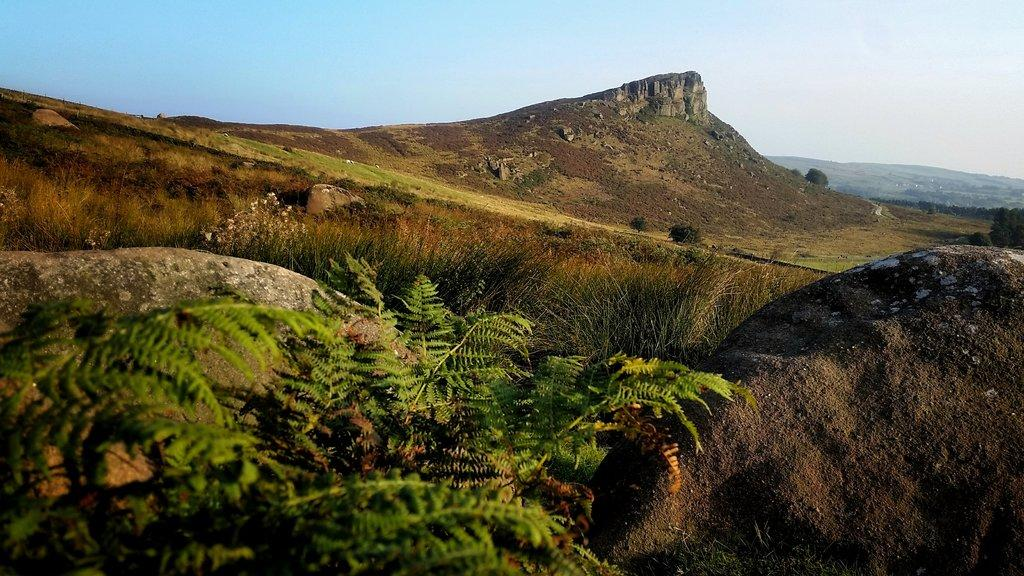What type of vegetation is on the left side of the image? There are trees on the left side of the image. What can be seen on the right side of the image? There is a rock on the right side of the image. What is the main feature in the middle of the image? There is a rocky hill in the middle of the image. What is the weather like in the image? The sky is visible at the top of the image, and it is sunny. What type of punishment is being handed out in the image? There is no indication of punishment in the image; it features trees, a rock, a rocky hill, and a sunny sky. Can you see a house in the image? There is no house present in the image. 